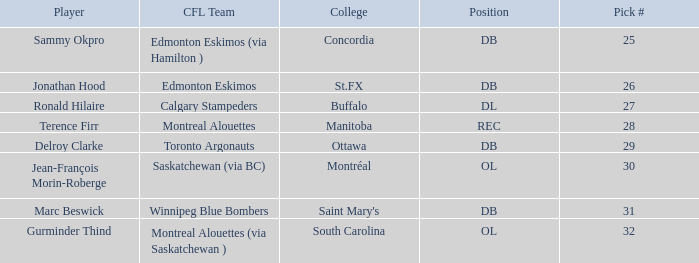Parse the table in full. {'header': ['Player', 'CFL Team', 'College', 'Position', 'Pick #'], 'rows': [['Sammy Okpro', 'Edmonton Eskimos (via Hamilton )', 'Concordia', 'DB', '25'], ['Jonathan Hood', 'Edmonton Eskimos', 'St.FX', 'DB', '26'], ['Ronald Hilaire', 'Calgary Stampeders', 'Buffalo', 'DL', '27'], ['Terence Firr', 'Montreal Alouettes', 'Manitoba', 'REC', '28'], ['Delroy Clarke', 'Toronto Argonauts', 'Ottawa', 'DB', '29'], ['Jean-François Morin-Roberge', 'Saskatchewan (via BC)', 'Montréal', 'OL', '30'], ['Marc Beswick', 'Winnipeg Blue Bombers', "Saint Mary's", 'DB', '31'], ['Gurminder Thind', 'Montreal Alouettes (via Saskatchewan )', 'South Carolina', 'OL', '32']]} Which CFL Team has a Pick # larger than 31? Montreal Alouettes (via Saskatchewan ). 